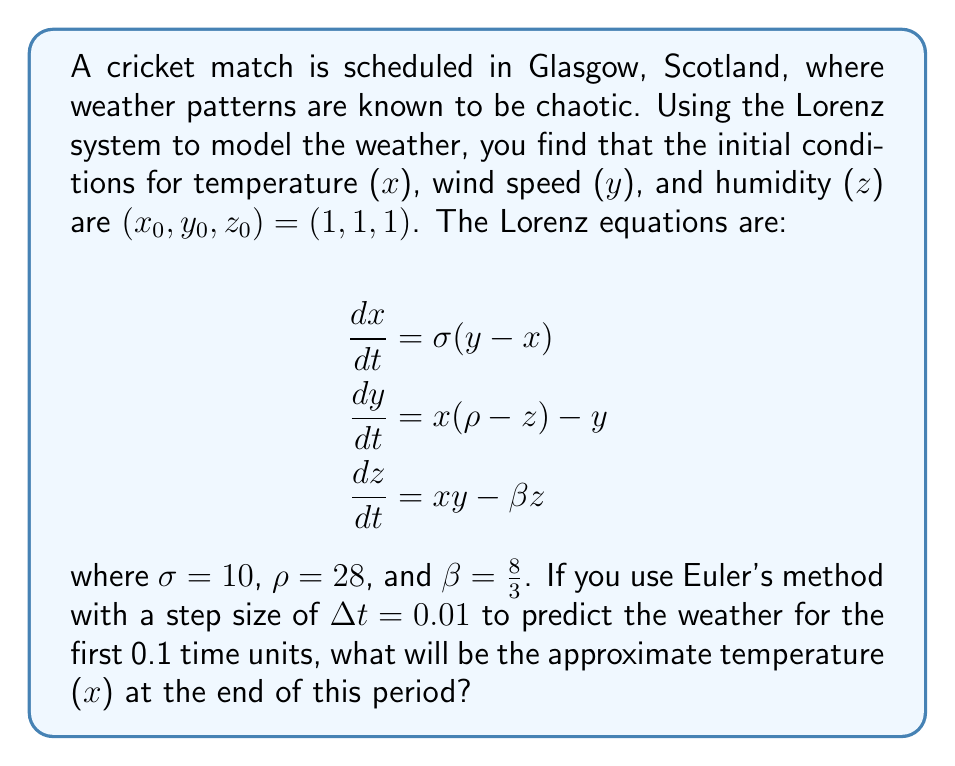What is the answer to this math problem? To solve this problem, we'll use Euler's method to approximate the solution of the Lorenz system. Euler's method is given by:

$$x_{n+1} = x_n + \Delta t \cdot f(x_n, y_n, z_n)$$
$$y_{n+1} = y_n + \Delta t \cdot g(x_n, y_n, z_n)$$
$$z_{n+1} = z_n + \Delta t \cdot h(x_n, y_n, z_n)$$

where $f$, $g$, and $h$ are the right-hand sides of the Lorenz equations.

Given:
- Initial conditions: $(x_0, y_0, z_0) = (1, 1, 1)$
- $\sigma = 10$, $\rho = 28$, $\beta = \frac{8}{3}$
- Step size: $\Delta t = 0.01$
- Number of steps: $0.1 / 0.01 = 10$ steps

Let's calculate the first few steps:

Step 1:
$x_1 = 1 + 0.01 \cdot 10(1 - 1) = 1$
$y_1 = 1 + 0.01 \cdot (1(28 - 1) - 1) = 1.26$
$z_1 = 1 + 0.01 \cdot (1 \cdot 1 - \frac{8}{3} \cdot 1) = 0.9733$

Step 2:
$x_2 = 1 + 0.01 \cdot 10(1.26 - 1) = 1.026$
$y_2 = 1.26 + 0.01 \cdot (1(28 - 0.9733) - 1.26) = 1.5193$
$z_2 = 0.9733 + 0.01 \cdot (1 \cdot 1.26 - \frac{8}{3} \cdot 0.9733) = 0.9741$

We continue this process for 10 steps. After the 10th step, we get:

$x_{10} \approx 1.7454$

This value represents the approximate temperature at the end of the 0.1 time units.
Answer: 1.7454 